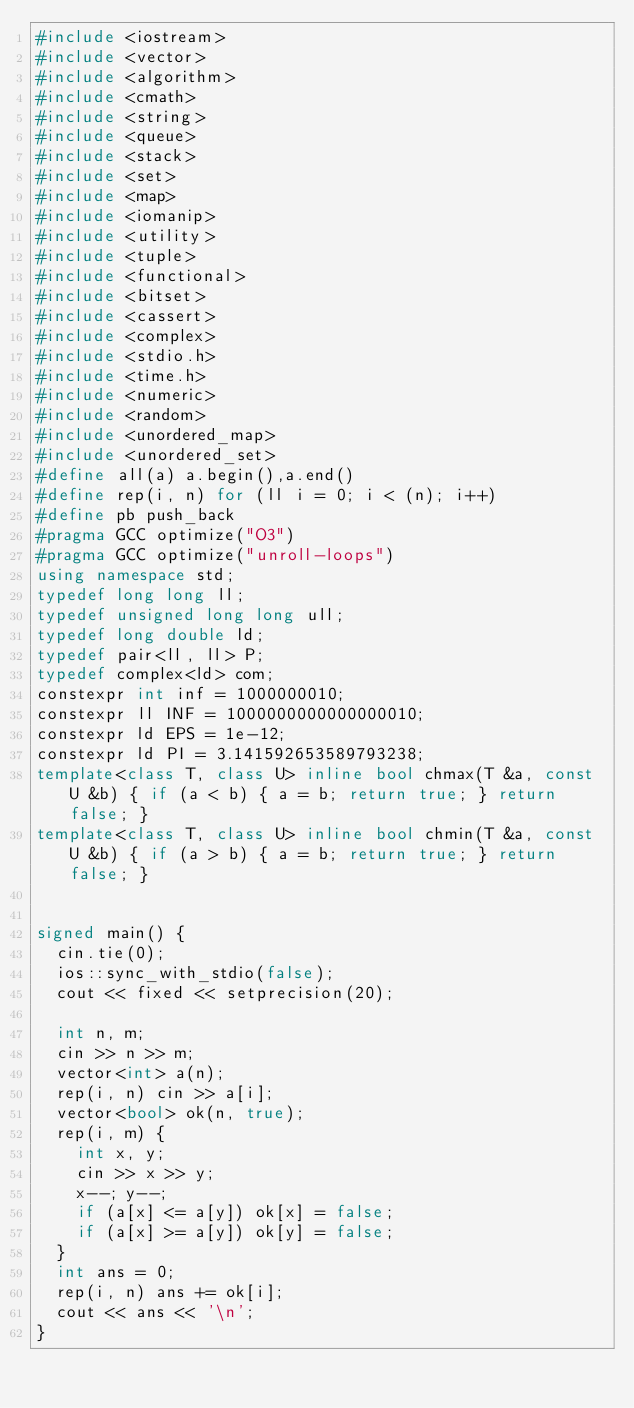<code> <loc_0><loc_0><loc_500><loc_500><_C++_>#include <iostream>
#include <vector>
#include <algorithm>
#include <cmath>
#include <string>
#include <queue>
#include <stack>
#include <set>
#include <map>
#include <iomanip>
#include <utility>
#include <tuple>
#include <functional>
#include <bitset>
#include <cassert>
#include <complex>
#include <stdio.h>
#include <time.h>
#include <numeric>
#include <random>
#include <unordered_map>
#include <unordered_set>
#define all(a) a.begin(),a.end()
#define rep(i, n) for (ll i = 0; i < (n); i++)
#define pb push_back
#pragma GCC optimize("O3")
#pragma GCC optimize("unroll-loops")
using namespace std;
typedef long long ll;
typedef unsigned long long ull;
typedef long double ld;
typedef pair<ll, ll> P;
typedef complex<ld> com;
constexpr int inf = 1000000010;
constexpr ll INF = 1000000000000000010;
constexpr ld EPS = 1e-12;
constexpr ld PI = 3.141592653589793238;
template<class T, class U> inline bool chmax(T &a, const U &b) { if (a < b) { a = b; return true; } return false; }
template<class T, class U> inline bool chmin(T &a, const U &b) { if (a > b) { a = b; return true; } return false; }


signed main() {
	cin.tie(0);
	ios::sync_with_stdio(false);
	cout << fixed << setprecision(20);

	int n, m;
	cin >> n >> m;
	vector<int> a(n);
	rep(i, n) cin >> a[i];
	vector<bool> ok(n, true);
	rep(i, m) {
		int x, y;
		cin >> x >> y;
		x--; y--;
		if (a[x] <= a[y]) ok[x] = false;
		if (a[x] >= a[y]) ok[y] = false;
	}
	int ans = 0;
	rep(i, n) ans += ok[i];
	cout << ans << '\n';
}</code> 